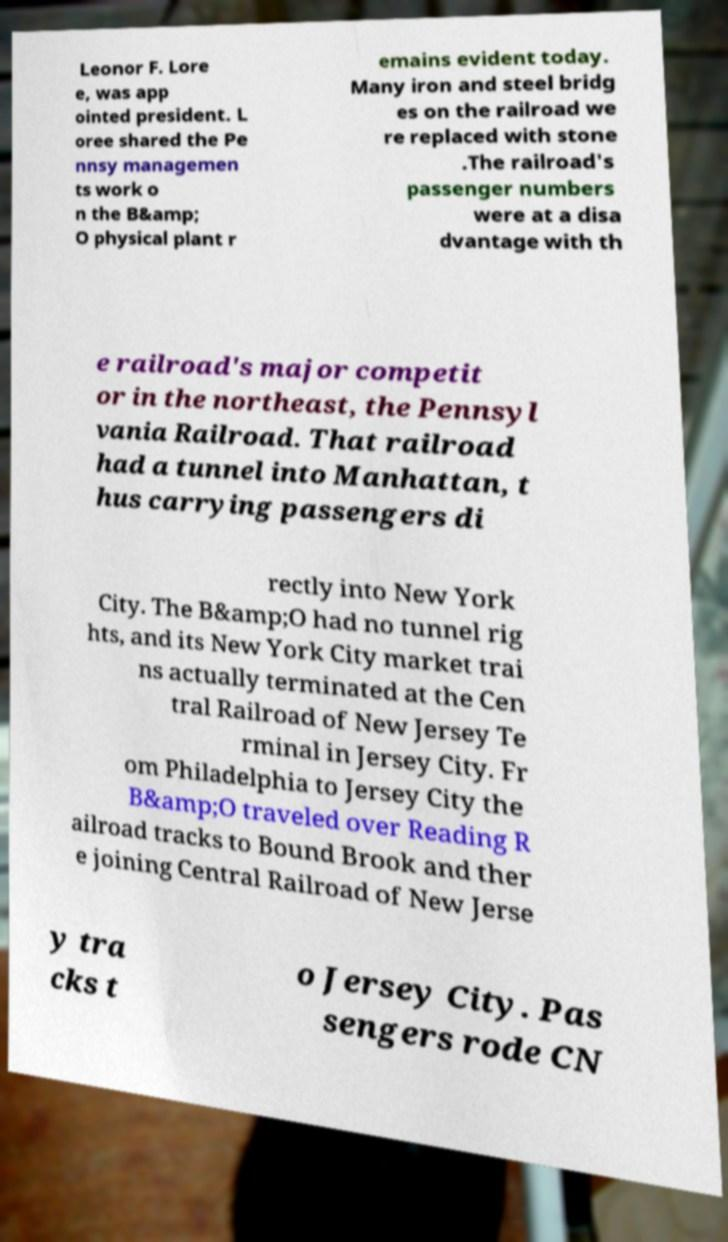What messages or text are displayed in this image? I need them in a readable, typed format. Leonor F. Lore e, was app ointed president. L oree shared the Pe nnsy managemen ts work o n the B&amp; O physical plant r emains evident today. Many iron and steel bridg es on the railroad we re replaced with stone .The railroad's passenger numbers were at a disa dvantage with th e railroad's major competit or in the northeast, the Pennsyl vania Railroad. That railroad had a tunnel into Manhattan, t hus carrying passengers di rectly into New York City. The B&amp;O had no tunnel rig hts, and its New York City market trai ns actually terminated at the Cen tral Railroad of New Jersey Te rminal in Jersey City. Fr om Philadelphia to Jersey City the B&amp;O traveled over Reading R ailroad tracks to Bound Brook and ther e joining Central Railroad of New Jerse y tra cks t o Jersey City. Pas sengers rode CN 